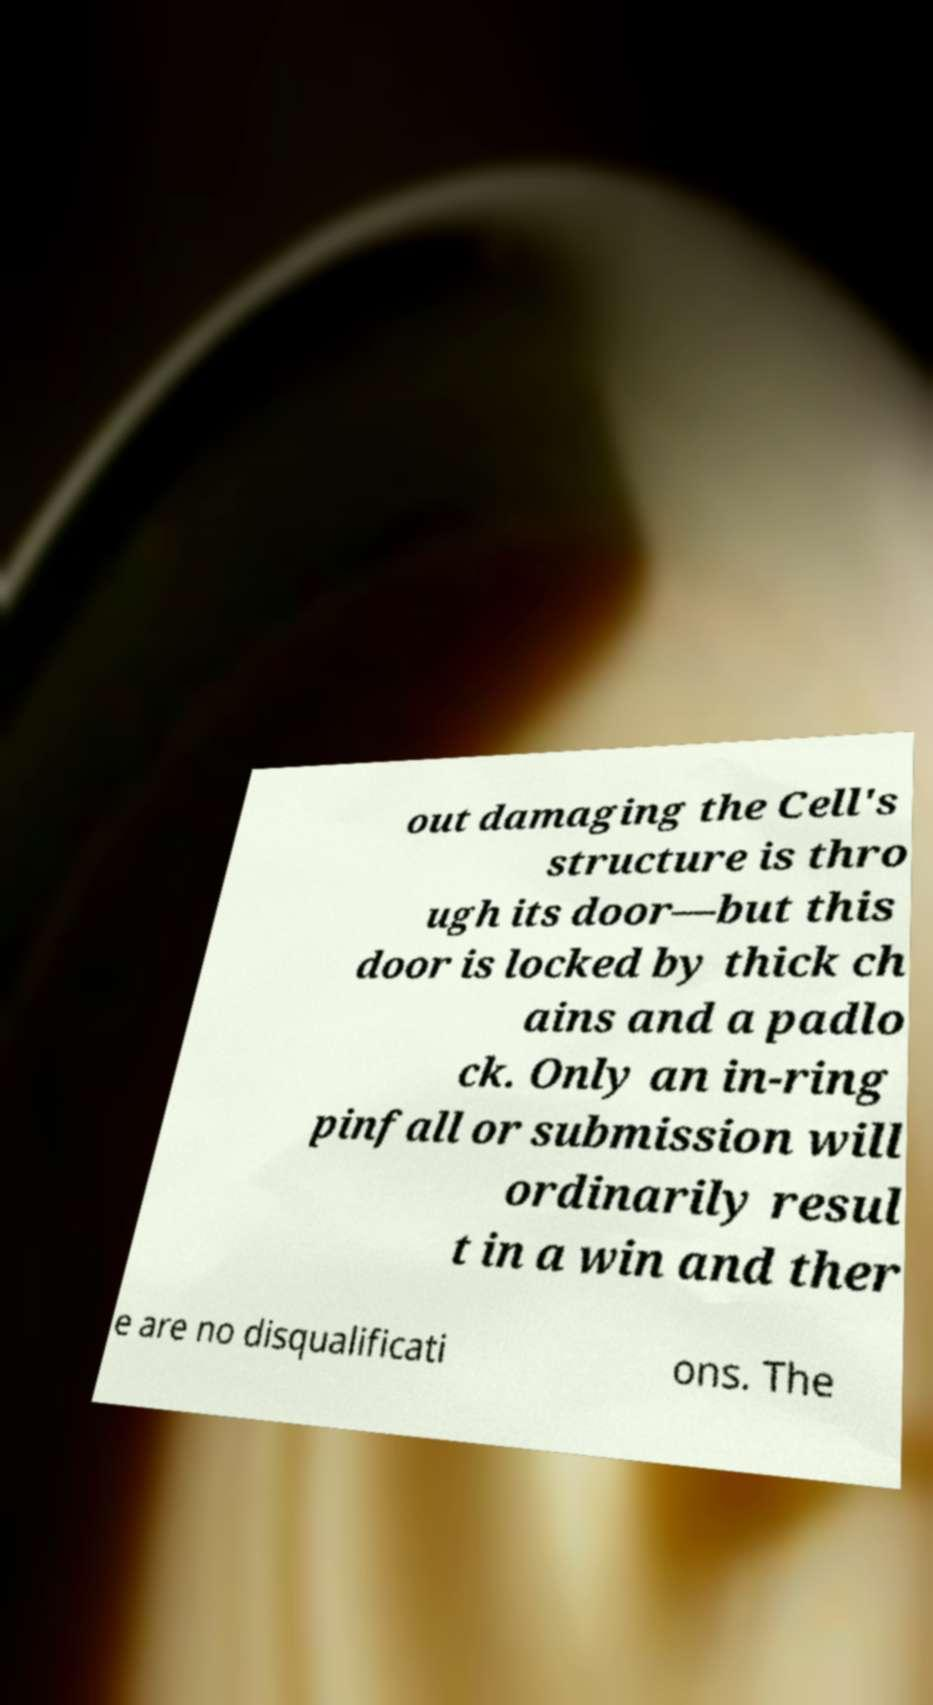Can you read and provide the text displayed in the image?This photo seems to have some interesting text. Can you extract and type it out for me? out damaging the Cell's structure is thro ugh its door—but this door is locked by thick ch ains and a padlo ck. Only an in-ring pinfall or submission will ordinarily resul t in a win and ther e are no disqualificati ons. The 